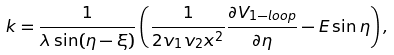Convert formula to latex. <formula><loc_0><loc_0><loc_500><loc_500>k = { \frac { 1 } { \lambda \sin ( \eta - \xi ) } } \left ( { \frac { 1 } { 2 v _ { 1 } v _ { 2 } x ^ { 2 } } } { \frac { \partial V _ { 1 - l o o p } } { \partial \eta } } - E \sin \eta \right ) ,</formula> 